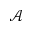<formula> <loc_0><loc_0><loc_500><loc_500>\mathcal { A }</formula> 